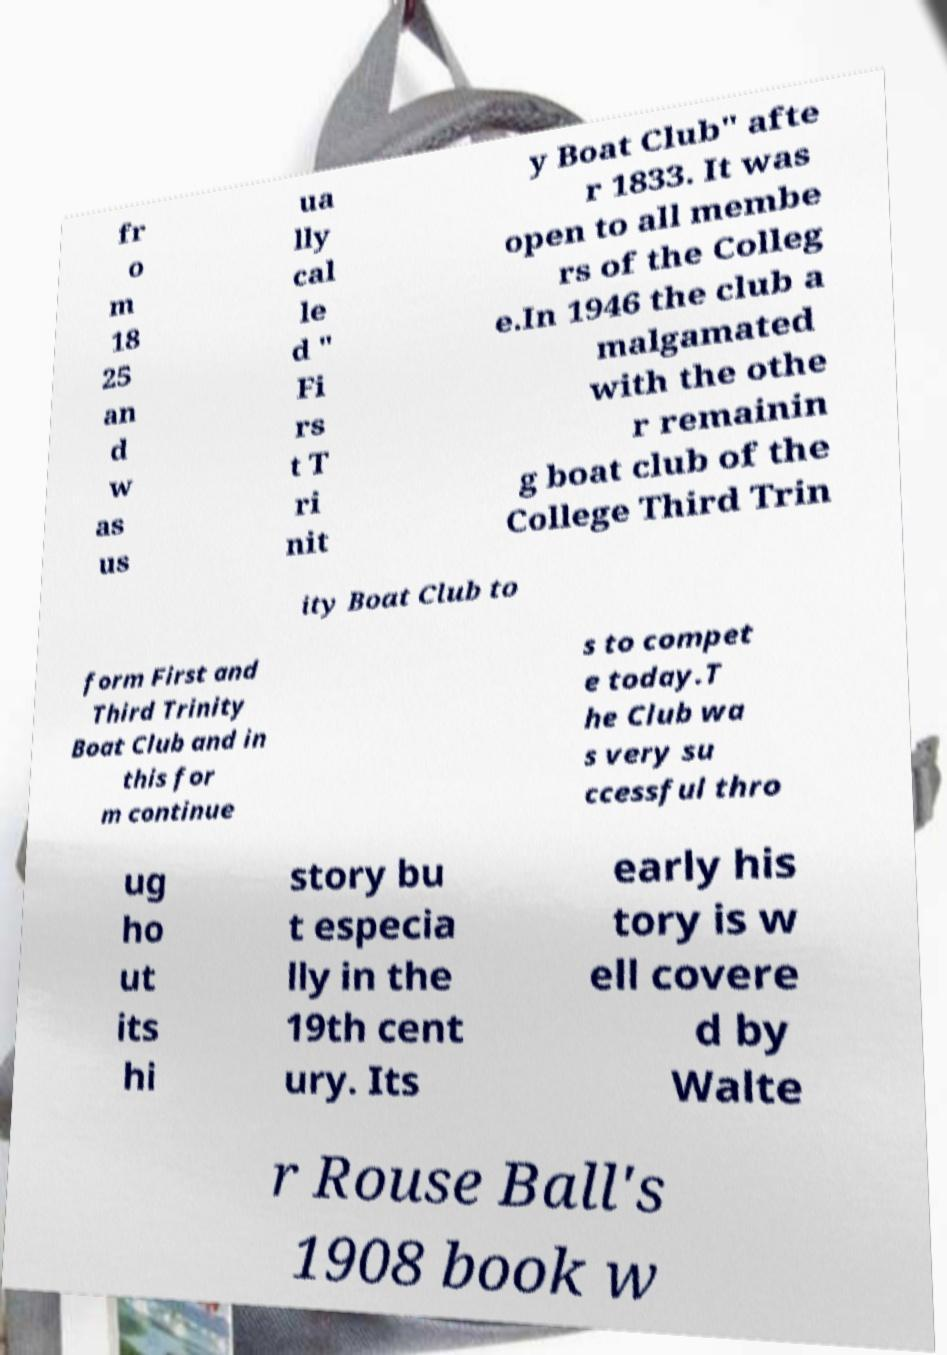Can you accurately transcribe the text from the provided image for me? fr o m 18 25 an d w as us ua lly cal le d " Fi rs t T ri nit y Boat Club" afte r 1833. It was open to all membe rs of the Colleg e.In 1946 the club a malgamated with the othe r remainin g boat club of the College Third Trin ity Boat Club to form First and Third Trinity Boat Club and in this for m continue s to compet e today.T he Club wa s very su ccessful thro ug ho ut its hi story bu t especia lly in the 19th cent ury. Its early his tory is w ell covere d by Walte r Rouse Ball's 1908 book w 